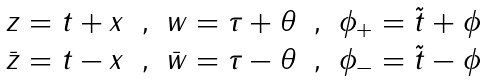<formula> <loc_0><loc_0><loc_500><loc_500>\begin{array} { c c c c c } z = t + x & , & w = \tau + \theta & , & \phi _ { + } = \tilde { t } + \phi \\ \bar { z } = t - x & , & \bar { w } = \tau - \theta & , & \phi _ { - } = \tilde { t } - \phi \end{array}</formula> 